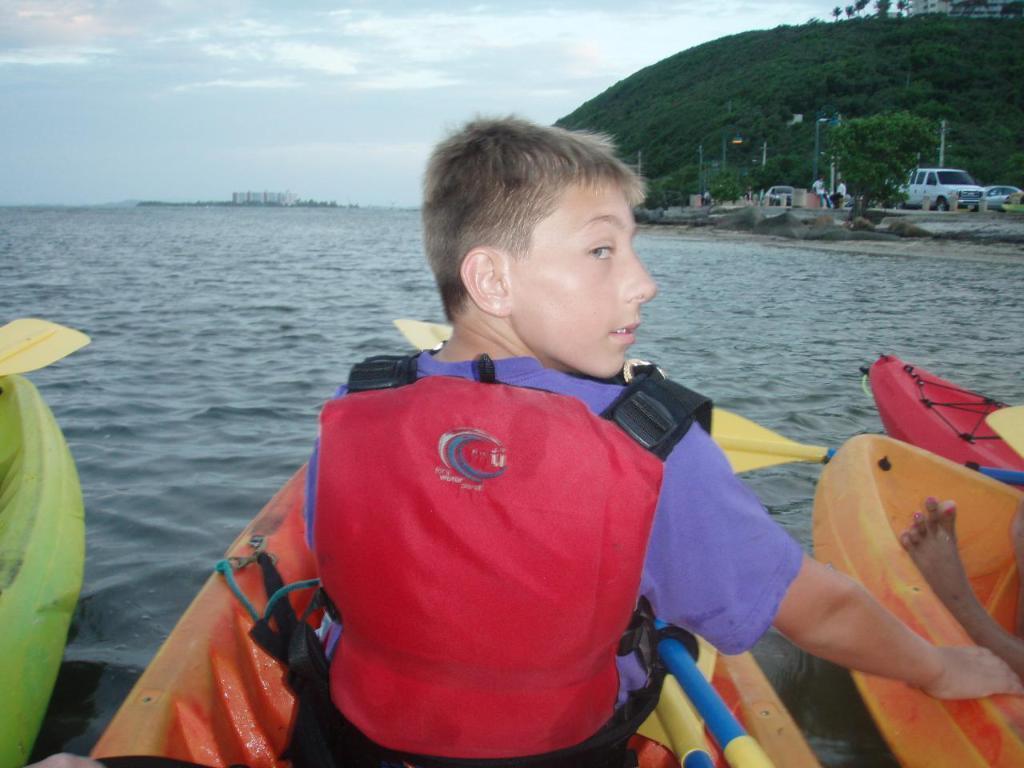In one or two sentences, can you explain what this image depicts? In the picture we can see a person wearing life jacket sitting in boat and in the background of the picture there is water, mountain and some vehicles parked and top of the picture there is clear sky. 